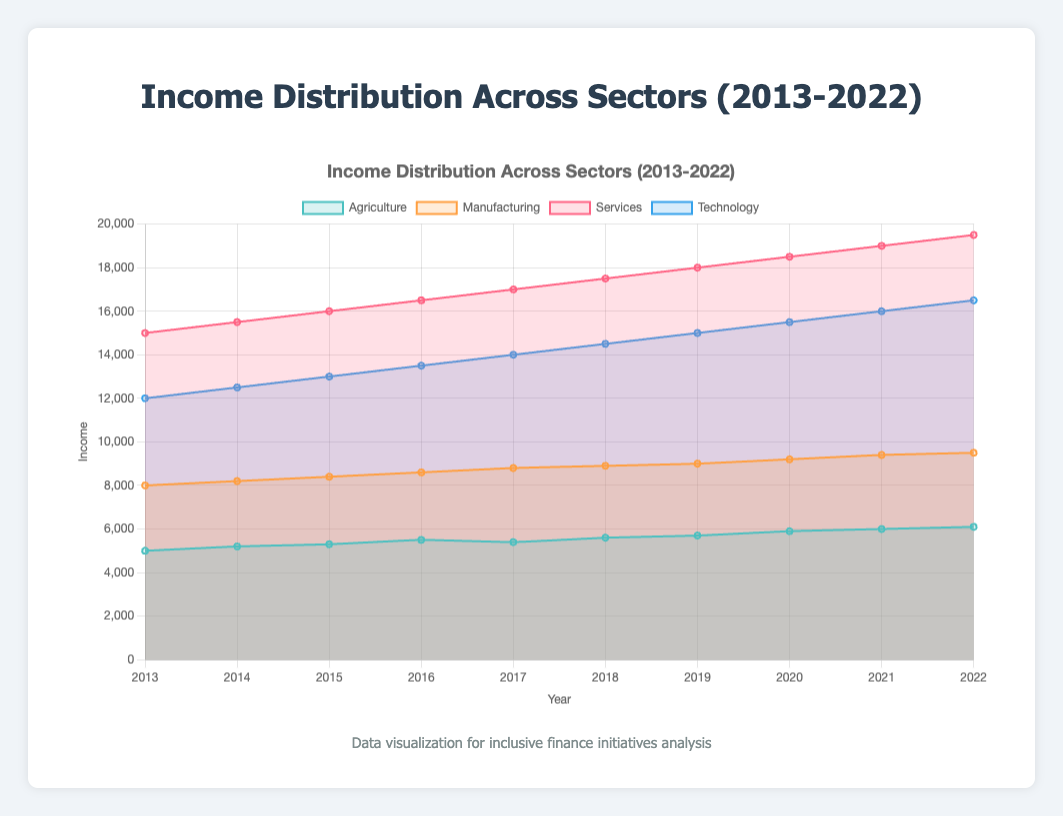What's the title of the figure? The title of the figure is displayed at the top and reads "Income Distribution Across Sectors (2013-2022)".
Answer: Income Distribution Across Sectors (2013-2022) How many years of data are represented in the figure? The x-axis lists the years from 2013 to 2022, which accounts for 10 years of data.
Answer: 10 Which sector had the highest income in 2022? In 2022, the Services sector had the highest income, as indicated by its data point being the highest on the chart.
Answer: Services What was the income increase in the Agriculture sector from 2013 to 2022? The income in the Agriculture sector in 2013 was 5000 and it increased to 6100 by 2022. The increase is 6100 - 5000 = 1100.
Answer: 1100 Which sector showed the most consistent increase over the decade? The Services sector showed a consistent increase each year, as indicated by a steady upward slope in the area chart without any declines.
Answer: Services Calculate the average income of the Technology sector over the decade. Sum the income values for Technology sector from 2013 to 2022: 12000 + 12500 + 13000 + 13500 + 14000 + 14500 + 15000 + 15500 + 16000 + 16500 = 142500. Divide by 10 (years): 142500/10 = 14250.
Answer: 14250 In which year did the Manufacturing sector first exceed 9000 in income? The Manufacturing sector first exceeded 9000 in income in 2019, as indicated by the data point for that year.
Answer: 2019 Compare the income growth of Technology and Manufacturing sectors from 2013 to 2022. Which grew more? Growth in Technology sector from 12000 to 16500 = 4500. Growth in Manufacturing sector from 8000 to 9500 = 1500. Therefore, the Technology sector grew more.
Answer: Technology What is the combined income of all sectors in the year 2020? Sum the incomes of all sectors for 2020: Agriculture = 5900, Manufacturing = 9200, Services = 18500, Technology = 15500. Combined income = 5900 + 9200 + 18500 + 15500 = 49100.
Answer: 49100 